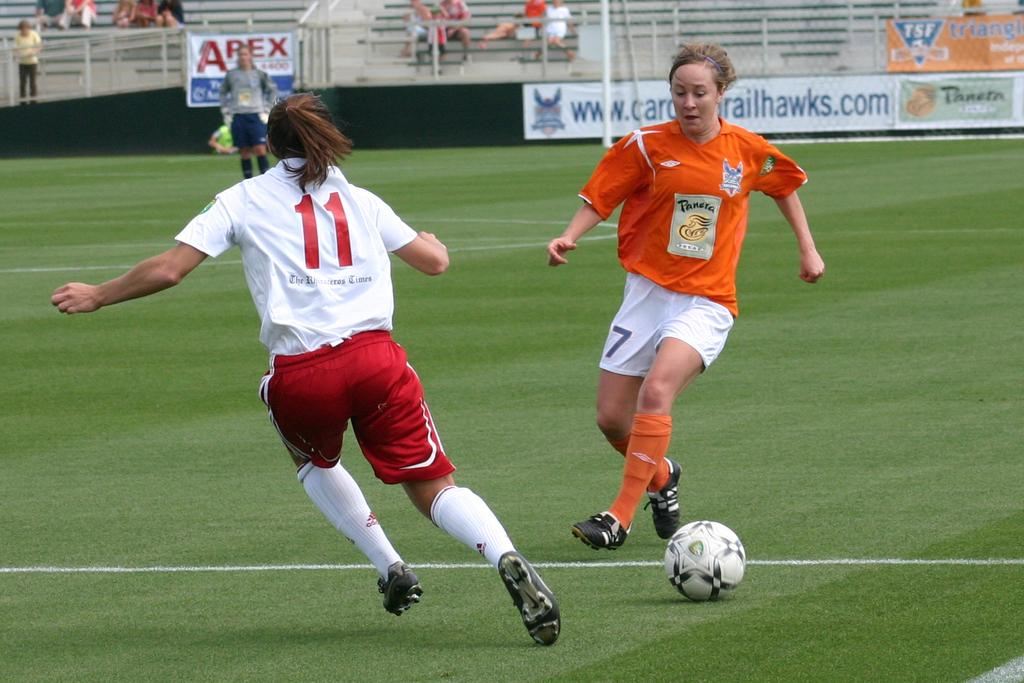Provide a one-sentence caption for the provided image. Two female soccer player with number 11 and 7. 